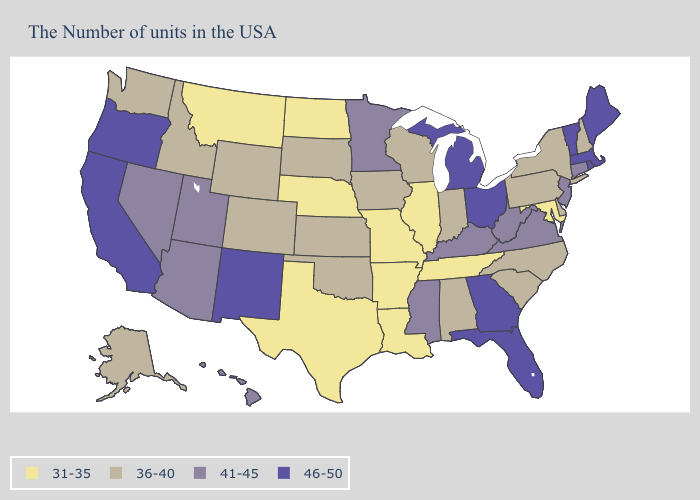Name the states that have a value in the range 46-50?
Be succinct. Maine, Massachusetts, Rhode Island, Vermont, Ohio, Florida, Georgia, Michigan, New Mexico, California, Oregon. Does Missouri have the same value as Wisconsin?
Answer briefly. No. Name the states that have a value in the range 36-40?
Short answer required. New Hampshire, New York, Delaware, Pennsylvania, North Carolina, South Carolina, Indiana, Alabama, Wisconsin, Iowa, Kansas, Oklahoma, South Dakota, Wyoming, Colorado, Idaho, Washington, Alaska. What is the value of North Dakota?
Concise answer only. 31-35. Does Virginia have the highest value in the USA?
Concise answer only. No. Name the states that have a value in the range 41-45?
Short answer required. Connecticut, New Jersey, Virginia, West Virginia, Kentucky, Mississippi, Minnesota, Utah, Arizona, Nevada, Hawaii. Name the states that have a value in the range 36-40?
Write a very short answer. New Hampshire, New York, Delaware, Pennsylvania, North Carolina, South Carolina, Indiana, Alabama, Wisconsin, Iowa, Kansas, Oklahoma, South Dakota, Wyoming, Colorado, Idaho, Washington, Alaska. What is the highest value in states that border Maine?
Write a very short answer. 36-40. What is the highest value in the USA?
Give a very brief answer. 46-50. Name the states that have a value in the range 31-35?
Answer briefly. Maryland, Tennessee, Illinois, Louisiana, Missouri, Arkansas, Nebraska, Texas, North Dakota, Montana. What is the value of Tennessee?
Keep it brief. 31-35. Which states hav the highest value in the Northeast?
Concise answer only. Maine, Massachusetts, Rhode Island, Vermont. Name the states that have a value in the range 41-45?
Give a very brief answer. Connecticut, New Jersey, Virginia, West Virginia, Kentucky, Mississippi, Minnesota, Utah, Arizona, Nevada, Hawaii. Name the states that have a value in the range 36-40?
Write a very short answer. New Hampshire, New York, Delaware, Pennsylvania, North Carolina, South Carolina, Indiana, Alabama, Wisconsin, Iowa, Kansas, Oklahoma, South Dakota, Wyoming, Colorado, Idaho, Washington, Alaska. Does Ohio have the highest value in the MidWest?
Answer briefly. Yes. 